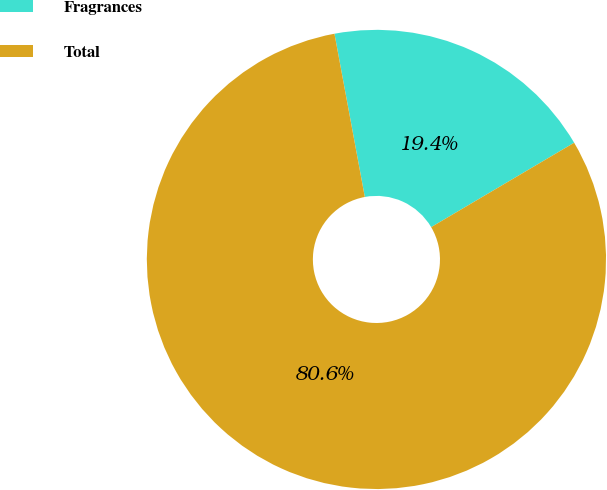Convert chart. <chart><loc_0><loc_0><loc_500><loc_500><pie_chart><fcel>Fragrances<fcel>Total<nl><fcel>19.44%<fcel>80.56%<nl></chart> 